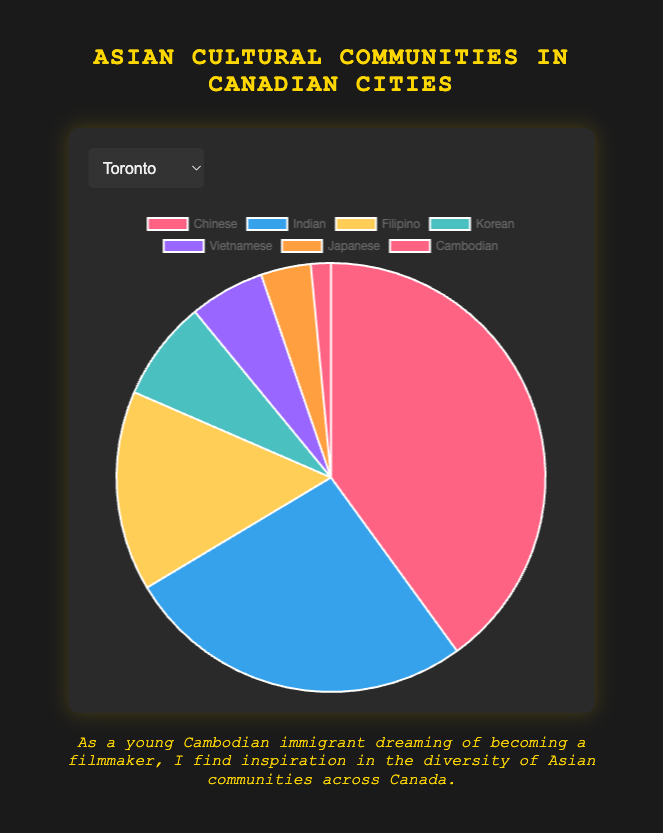What is the percentage of the Filipino community in Toronto compared to the total Asian population in Toronto? Sum the total Asian population in Toronto: 530,000 (Chinese) + 350,000 (Indian) + 200,000 (Filipino) + 100,000 (Korean) + 75,000 (Vietnamese) + 50,000 (Japanese) + 20,000 (Cambodian) = 1,325,000. The Filipino community makes up 200,000 of this total. Calculate the percentage: (200,000 / 1,325,000) * 100 = 15.1%
Answer: 15.1% Which city has the largest Cambodian community? Compare the Cambodian population across all cities: Toronto (20,000), Vancouver (15,000), Montreal (10,000), Calgary (5,000), Edmonton (5,000), Ottawa (3,000), Winnipeg (2,000). Toronto has the largest Cambodian community.
Answer: Toronto How does the Indian community in Vancouver compare to that in Calgary? Compare the Indian population in Vancouver (250,000) with Calgary (100,000). Vancouver has 150,000 more Indians than Calgary (250,000 - 100,000 = 150,000).
Answer: Vancouver has 150,000 more If the combined population of the Korean and Indian communities in Montreal is removed from the total Asian population in Montreal, what percentage of the original total remains? Sum the total Asian population in Montreal: 150,000 (Chinese) + 90,000 (Indian) + 60,000 (Filipino) + 30,000 (Korean) + 45,000 (Vietnamese) + 25,000 (Japanese) + 10,000 (Cambodian) = 410,000. The combined Korean and Indian population is 30,000 (Korean) + 90,000 (Indian) = 120,000. Subtract this from the total: 410,000 - 120,000 = 290,000. Calculate the percentage: (290,000 / 410,000) * 100 = 70.7%
Answer: 70.7% Which city has the smallest Chinese community, and what is the size difference compared to the city with the largest Chinese community? Find the Chinese populations: Toronto (530,000), Vancouver (470,000), Montreal (150,000), Calgary (120,000), Edmonton (110,000), Ottawa (70,000), Winnipeg (50,000). Winnipeg has the smallest Chinese community with 50,000. The largest is in Toronto with 530,000. The size difference is 530,000 - 50,000 = 480,000.
Answer: Winnipeg; 480,000 What is the ratio of the Vietnamese community in Edmonton to the Japanese community in Ottawa? The Vietnamese population in Edmonton is 15,000. The Japanese population in Ottawa is 7,000. The ratio is 15,000:7,000, which simplifies to approximately 2.14:1.
Answer: 2.14:1 How many more Chinese people are there in Toronto than in Montreal? The Chinese population in Toronto is 530,000, and in Montreal, it is 150,000. Subtract to find the difference: 530,000 - 150,000 = 380,000.
Answer: 380,000 What percentage of Calgary's total Asian population is Cambodian? Sum the total Asian population in Calgary: 120,000 (Chinese) + 100,000 (Indian) + 75,000 (Filipino) + 25,000 (Korean) + 20,000 (Vietnamese) + 15,000 (Japanese) + 5,000 (Cambodian) = 360,000. The Cambodian community is 5,000. Calculate the percentage: (5,000 / 360,000) * 100 = 1.4%
Answer: 1.4% 